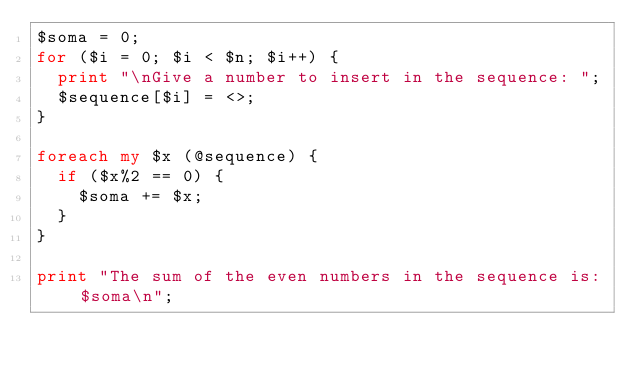<code> <loc_0><loc_0><loc_500><loc_500><_Perl_>$soma = 0;
for ($i = 0; $i < $n; $i++) {
  print "\nGive a number to insert in the sequence: ";
  $sequence[$i] = <>;
}

foreach my $x (@sequence) {
  if ($x%2 == 0) {
    $soma += $x;
  }
}

print "The sum of the even numbers in the sequence is: $soma\n";
</code> 